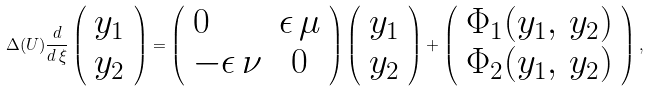<formula> <loc_0><loc_0><loc_500><loc_500>\Delta ( U ) \frac { d } { d \, \xi } \left ( \begin{array} { c } y _ { 1 } \\ y _ { 2 } \end{array} \right ) = \left ( \begin{array} { l c } 0 & \epsilon \, \mu \\ - \epsilon \, \nu & 0 \end{array} \right ) \left ( \begin{array} { c } y _ { 1 } \\ y _ { 2 } \end{array} \right ) + \left ( \begin{array} { c } \Phi _ { 1 } ( y _ { 1 } , \, y _ { 2 } ) \\ \Phi _ { 2 } ( y _ { 1 } , \, y _ { 2 } ) \end{array} \right ) ,</formula> 